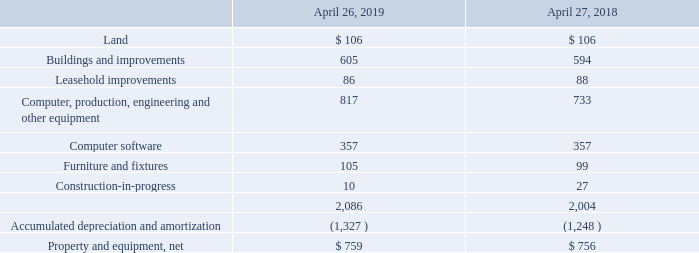Property and equipment, net (in millions):
In September 2017, we entered into an agreement to sell certain land and buildings located in Sunnyvale, California, with a book value of $118 million, for a total of $306 million, through two separate and independent closings. Upon the completion of the first closing in fiscal 2018, we consummated the sale of properties with a net book value of $66 million for cash proceeds of $210 million, resulting in a gain, net of direct selling costs, of $142 million. The remaining properties, consisting of land with a net book value of $52 million, were classified as assets held-for-sale, and included as other current assets in our consolidated balance sheets as of April 26, 2019 and April 27, 2018. We will consummate the sale of these properties, and receive cash proceeds of $96 million, upon the completion of the second closing, which is expected to occur within the next 12 months. That closing is subject to due diligence, certain termination rights and customary closing conditions, including local governmental approval of the subdivision of a land parcel.
What agreement did the company enter in September 2017? To sell certain land and buildings located in sunnyvale, california. What was the amount of buildings and improvements in 2019?
Answer scale should be: million. 605. Which years does the table provide information for net property and equipment? 2019, 2018. How many years did buildings and improvements exceed $600 million? 2019
Answer: 1. What was the change in Computer, production, engineering and other equipment between 2018 and 2019?
Answer scale should be: million. 817-733
Answer: 84. What was the percentage change in the amount of leasehold improvements between 2018 and 2019?
Answer scale should be: percent. (86-88)/88
Answer: -2.27. 